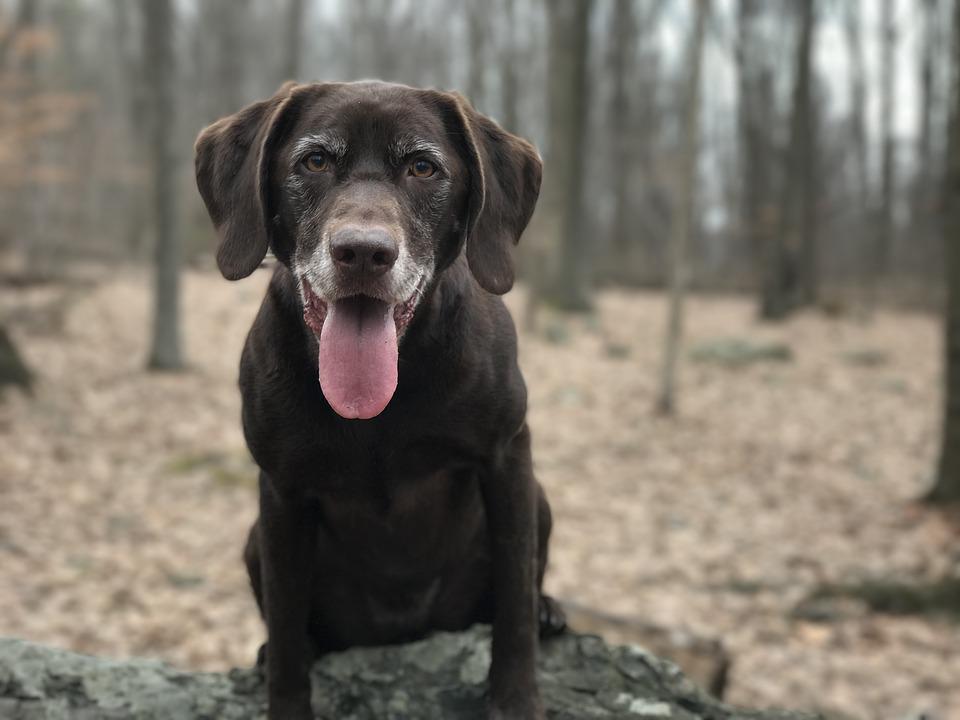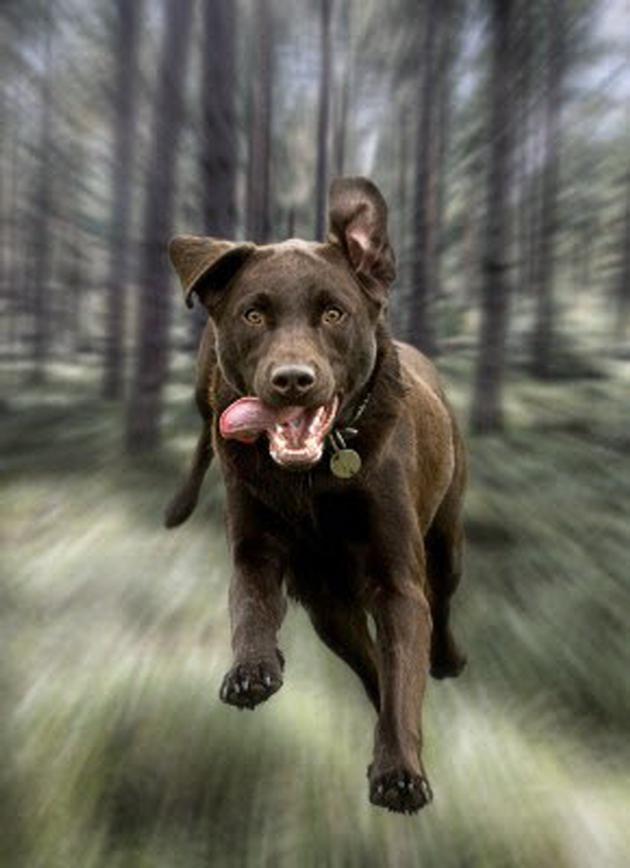The first image is the image on the left, the second image is the image on the right. For the images shown, is this caption "Both images contain a dark colored dog." true? Answer yes or no. Yes. The first image is the image on the left, the second image is the image on the right. Analyze the images presented: Is the assertion "Both dogs are facing opposite directions." valid? Answer yes or no. No. 